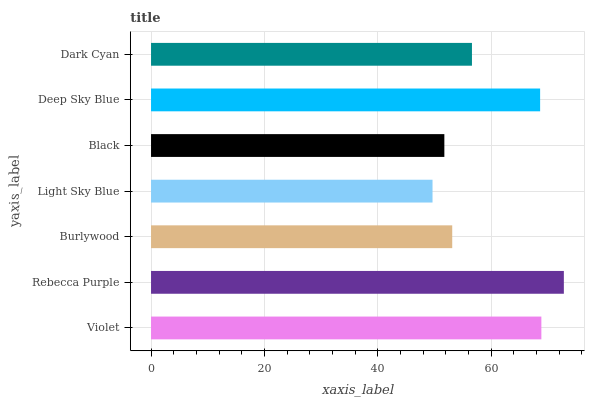Is Light Sky Blue the minimum?
Answer yes or no. Yes. Is Rebecca Purple the maximum?
Answer yes or no. Yes. Is Burlywood the minimum?
Answer yes or no. No. Is Burlywood the maximum?
Answer yes or no. No. Is Rebecca Purple greater than Burlywood?
Answer yes or no. Yes. Is Burlywood less than Rebecca Purple?
Answer yes or no. Yes. Is Burlywood greater than Rebecca Purple?
Answer yes or no. No. Is Rebecca Purple less than Burlywood?
Answer yes or no. No. Is Dark Cyan the high median?
Answer yes or no. Yes. Is Dark Cyan the low median?
Answer yes or no. Yes. Is Violet the high median?
Answer yes or no. No. Is Burlywood the low median?
Answer yes or no. No. 